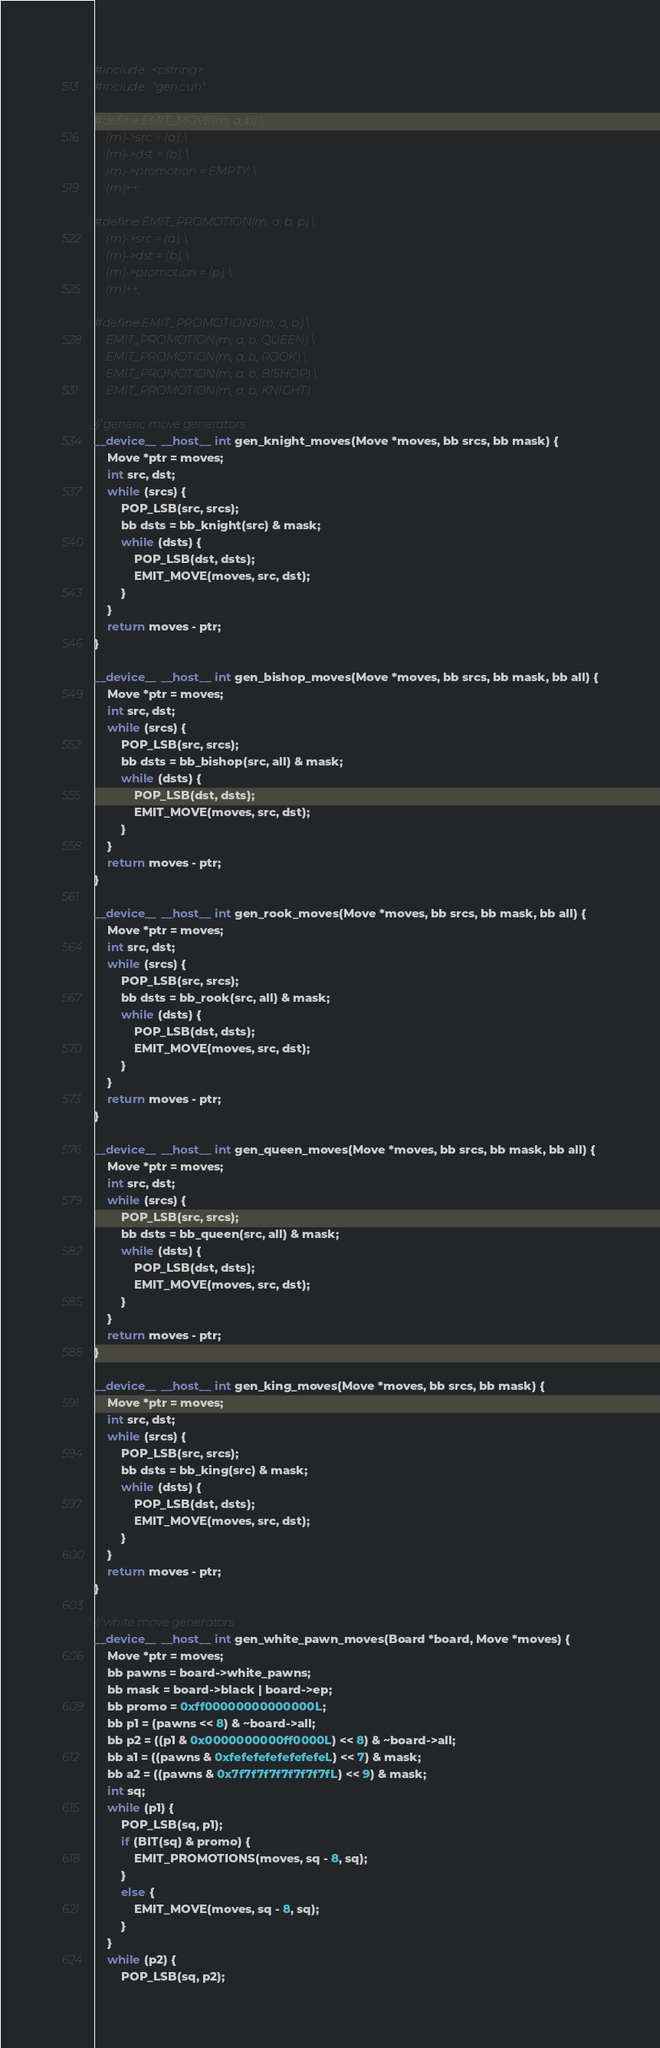<code> <loc_0><loc_0><loc_500><loc_500><_Cuda_>#include <cstring>
#include "gen.cuh"

#define EMIT_MOVE(m, a, b) \
    (m)->src = (a); \
    (m)->dst = (b); \
    (m)->promotion = EMPTY; \
    (m)++;

#define EMIT_PROMOTION(m, a, b, p) \
    (m)->src = (a); \
    (m)->dst = (b); \
    (m)->promotion = (p); \
    (m)++;

#define EMIT_PROMOTIONS(m, a, b) \
    EMIT_PROMOTION(m, a, b, QUEEN) \
    EMIT_PROMOTION(m, a, b, ROOK) \
    EMIT_PROMOTION(m, a, b, BISHOP) \
    EMIT_PROMOTION(m, a, b, KNIGHT)

// generic move generators
__device__ __host__ int gen_knight_moves(Move *moves, bb srcs, bb mask) {
    Move *ptr = moves;
    int src, dst;
    while (srcs) {
        POP_LSB(src, srcs);
        bb dsts = bb_knight(src) & mask;
        while (dsts) {
            POP_LSB(dst, dsts);
            EMIT_MOVE(moves, src, dst);
        }
    }
    return moves - ptr;
}

__device__ __host__ int gen_bishop_moves(Move *moves, bb srcs, bb mask, bb all) {
    Move *ptr = moves;
    int src, dst;
    while (srcs) {
        POP_LSB(src, srcs);
        bb dsts = bb_bishop(src, all) & mask;
        while (dsts) {
            POP_LSB(dst, dsts);
            EMIT_MOVE(moves, src, dst);
        }
    }
    return moves - ptr;
}

__device__ __host__ int gen_rook_moves(Move *moves, bb srcs, bb mask, bb all) {
    Move *ptr = moves;
    int src, dst;
    while (srcs) {
        POP_LSB(src, srcs);
        bb dsts = bb_rook(src, all) & mask;
        while (dsts) {
            POP_LSB(dst, dsts);
            EMIT_MOVE(moves, src, dst);
        }
    }
    return moves - ptr;
}

__device__ __host__ int gen_queen_moves(Move *moves, bb srcs, bb mask, bb all) {
    Move *ptr = moves;
    int src, dst;
    while (srcs) {
        POP_LSB(src, srcs);
        bb dsts = bb_queen(src, all) & mask;
        while (dsts) {
            POP_LSB(dst, dsts);
            EMIT_MOVE(moves, src, dst);
        }
    }
    return moves - ptr;
}

__device__ __host__ int gen_king_moves(Move *moves, bb srcs, bb mask) {
    Move *ptr = moves;
    int src, dst;
    while (srcs) {
        POP_LSB(src, srcs);
        bb dsts = bb_king(src) & mask;
        while (dsts) {
            POP_LSB(dst, dsts);
            EMIT_MOVE(moves, src, dst);
        }
    }
    return moves - ptr;
}

// white move generators
__device__ __host__ int gen_white_pawn_moves(Board *board, Move *moves) {
    Move *ptr = moves;
    bb pawns = board->white_pawns;
    bb mask = board->black | board->ep;
    bb promo = 0xff00000000000000L;
    bb p1 = (pawns << 8) & ~board->all;
    bb p2 = ((p1 & 0x0000000000ff0000L) << 8) & ~board->all;
    bb a1 = ((pawns & 0xfefefefefefefefeL) << 7) & mask;
    bb a2 = ((pawns & 0x7f7f7f7f7f7f7f7fL) << 9) & mask;
    int sq;
    while (p1) {
        POP_LSB(sq, p1);
        if (BIT(sq) & promo) {
            EMIT_PROMOTIONS(moves, sq - 8, sq);
        }
        else {
            EMIT_MOVE(moves, sq - 8, sq);
        }
    }
    while (p2) {
        POP_LSB(sq, p2);</code> 